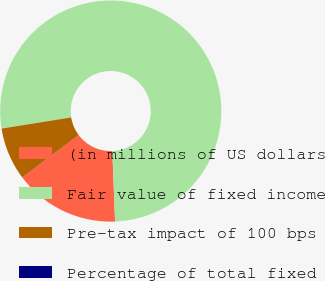Convert chart to OTSL. <chart><loc_0><loc_0><loc_500><loc_500><pie_chart><fcel>(in millions of US dollars<fcel>Fair value of fixed income<fcel>Pre-tax impact of 100 bps<fcel>Percentage of total fixed<nl><fcel>15.39%<fcel>76.91%<fcel>7.7%<fcel>0.01%<nl></chart> 